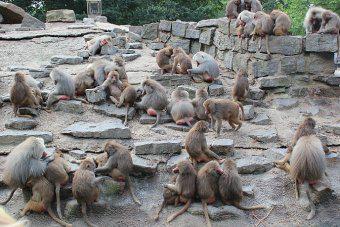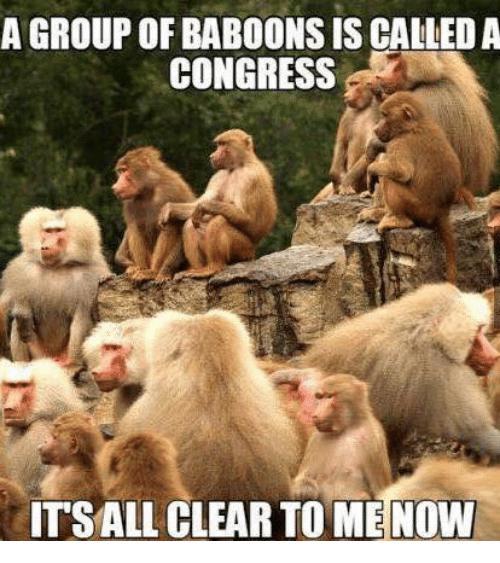The first image is the image on the left, the second image is the image on the right. Considering the images on both sides, is "Exactly two baboons are in the foreground in at least one image." valid? Answer yes or no. No. 